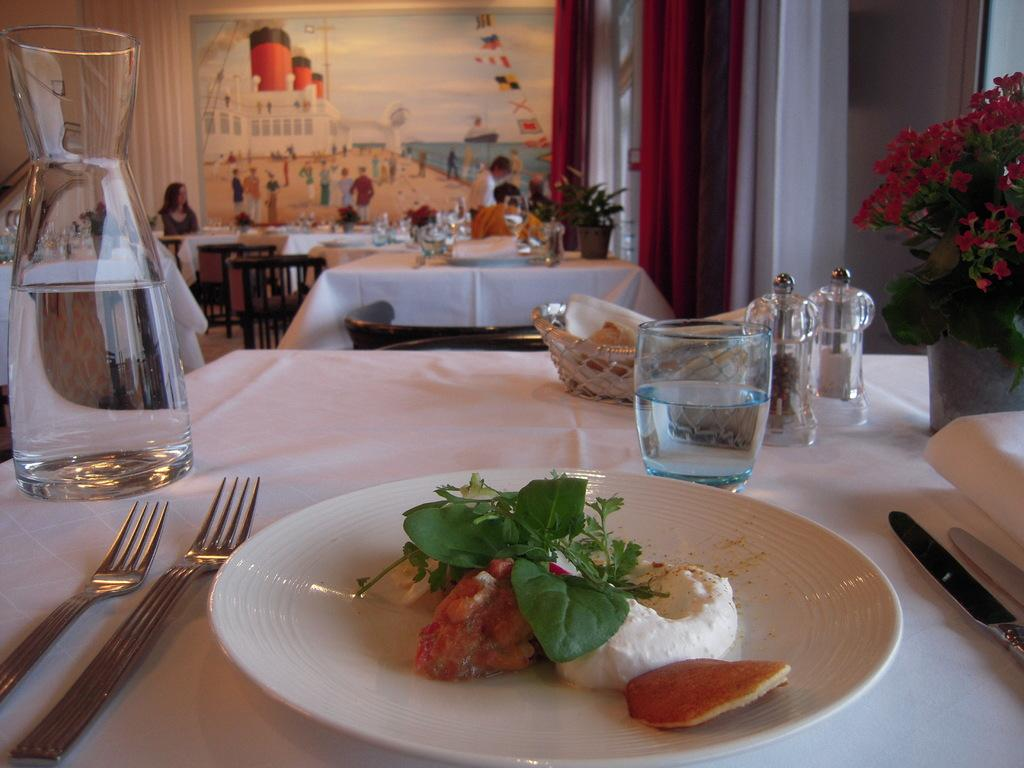What piece of furniture is present in the image? There is a table in the image. What is placed on the table? There is a water jar, a water glass, and a plate with food on the table. What type of substance is the giraffe chewing on in the image? There is no giraffe present in the image, so it is not possible to determine what, if any, substance it might be chewing on. 